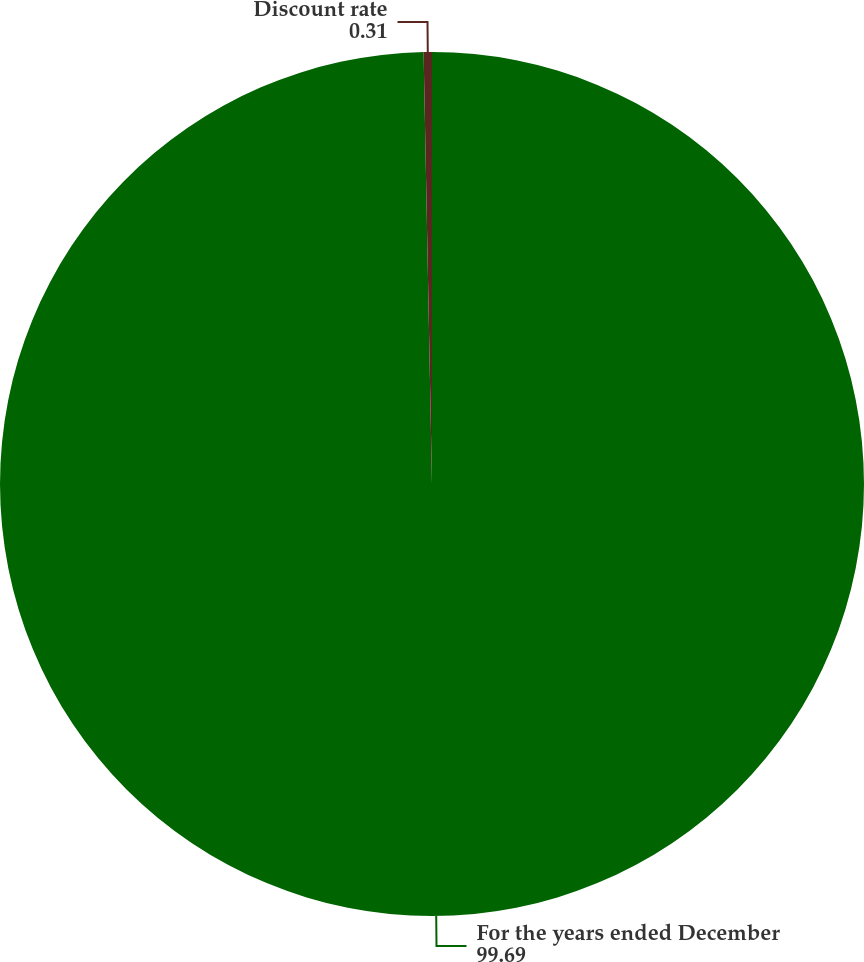Convert chart to OTSL. <chart><loc_0><loc_0><loc_500><loc_500><pie_chart><fcel>For the years ended December<fcel>Discount rate<nl><fcel>99.69%<fcel>0.31%<nl></chart> 